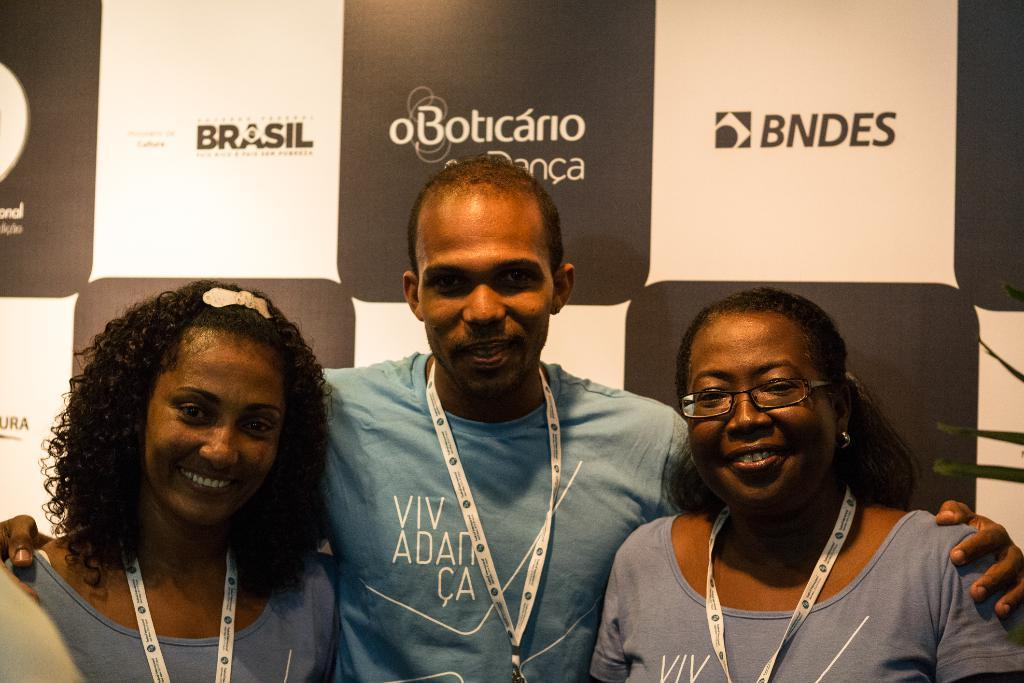How many people are in the image? There are three persons in the image. What can be observed about the persons in the image? The persons are wearing tags. What is visible in the background of the image? There is a banner with text in the background. What is the gender distribution among the three persons? There are two women and one man among the three persons. What type of substance is stored on the shelf in the image? There is no shelf present in the image, so it is not possible to determine what substance might be stored on it. 